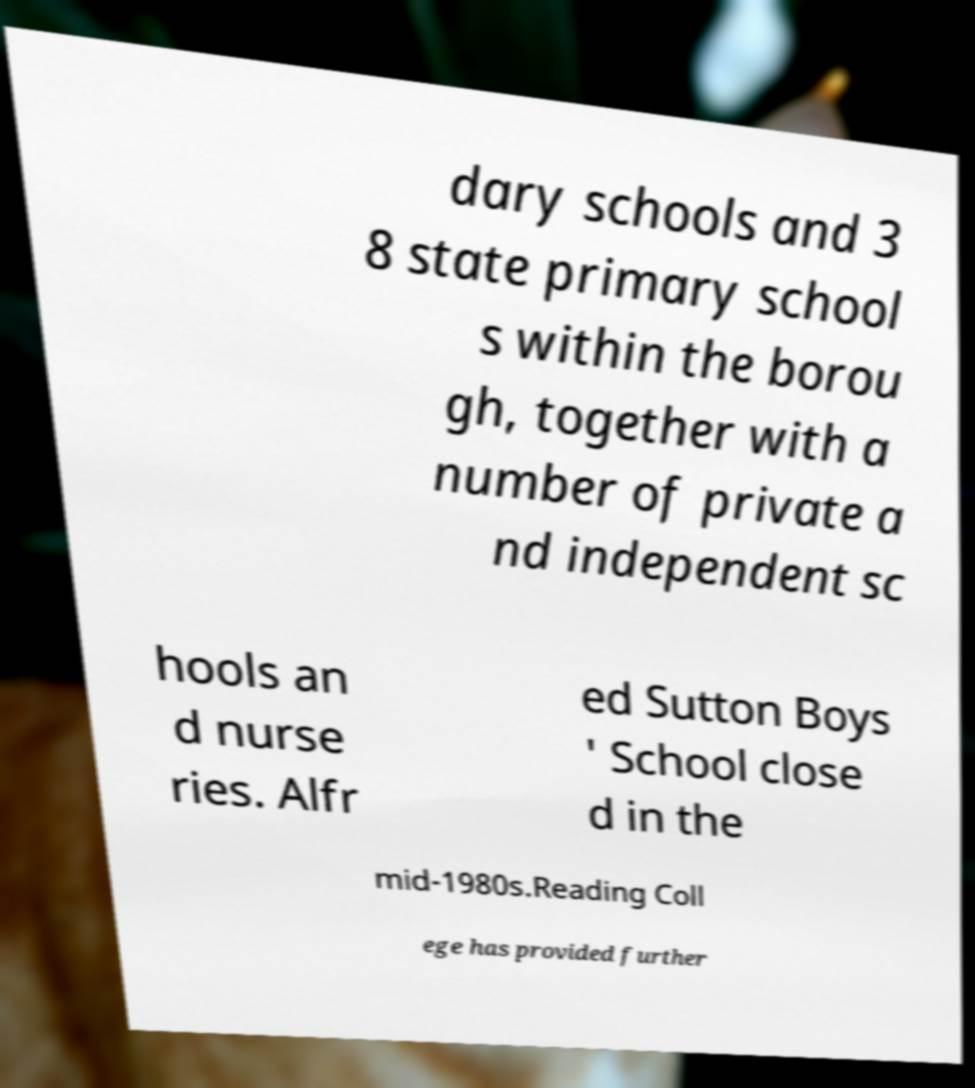For documentation purposes, I need the text within this image transcribed. Could you provide that? dary schools and 3 8 state primary school s within the borou gh, together with a number of private a nd independent sc hools an d nurse ries. Alfr ed Sutton Boys ' School close d in the mid-1980s.Reading Coll ege has provided further 